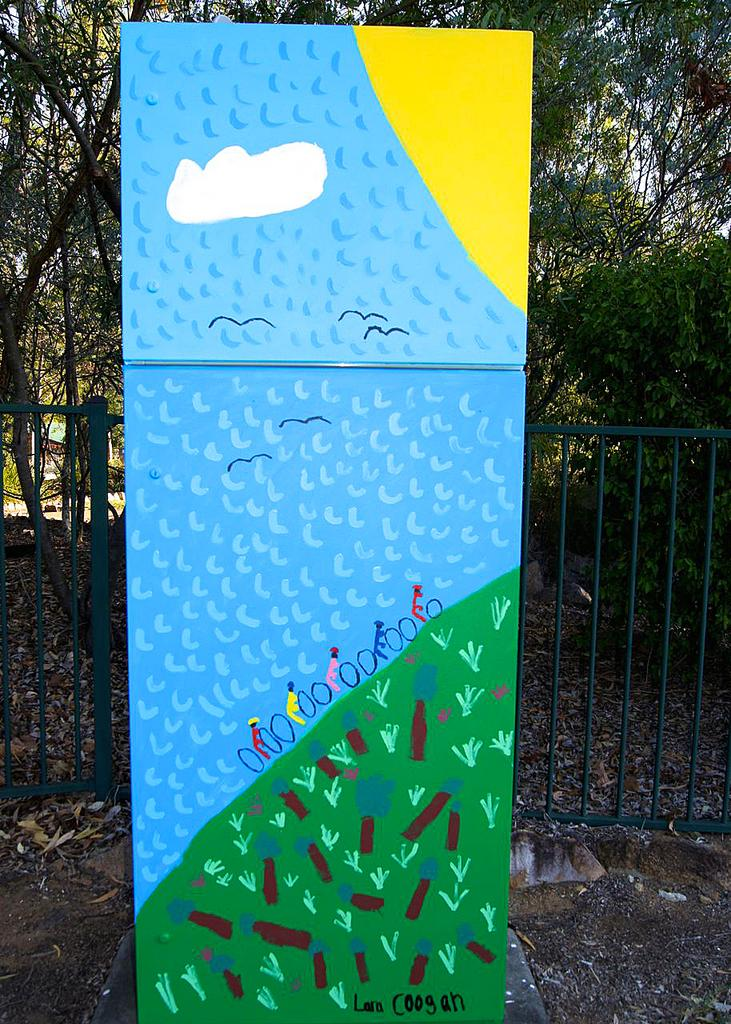What is the main feature of the image? The main feature of the image is the presence of many trees and plants. What else can be seen in the image besides the trees and plants? There is a painting on a board in the image. What is depicted in the painting? The painting depicts a few persons, birds, the sky, and other objects. Can you hear the field crying in the image? There is no field present in the image, nor is there any indication of sound or crying. 